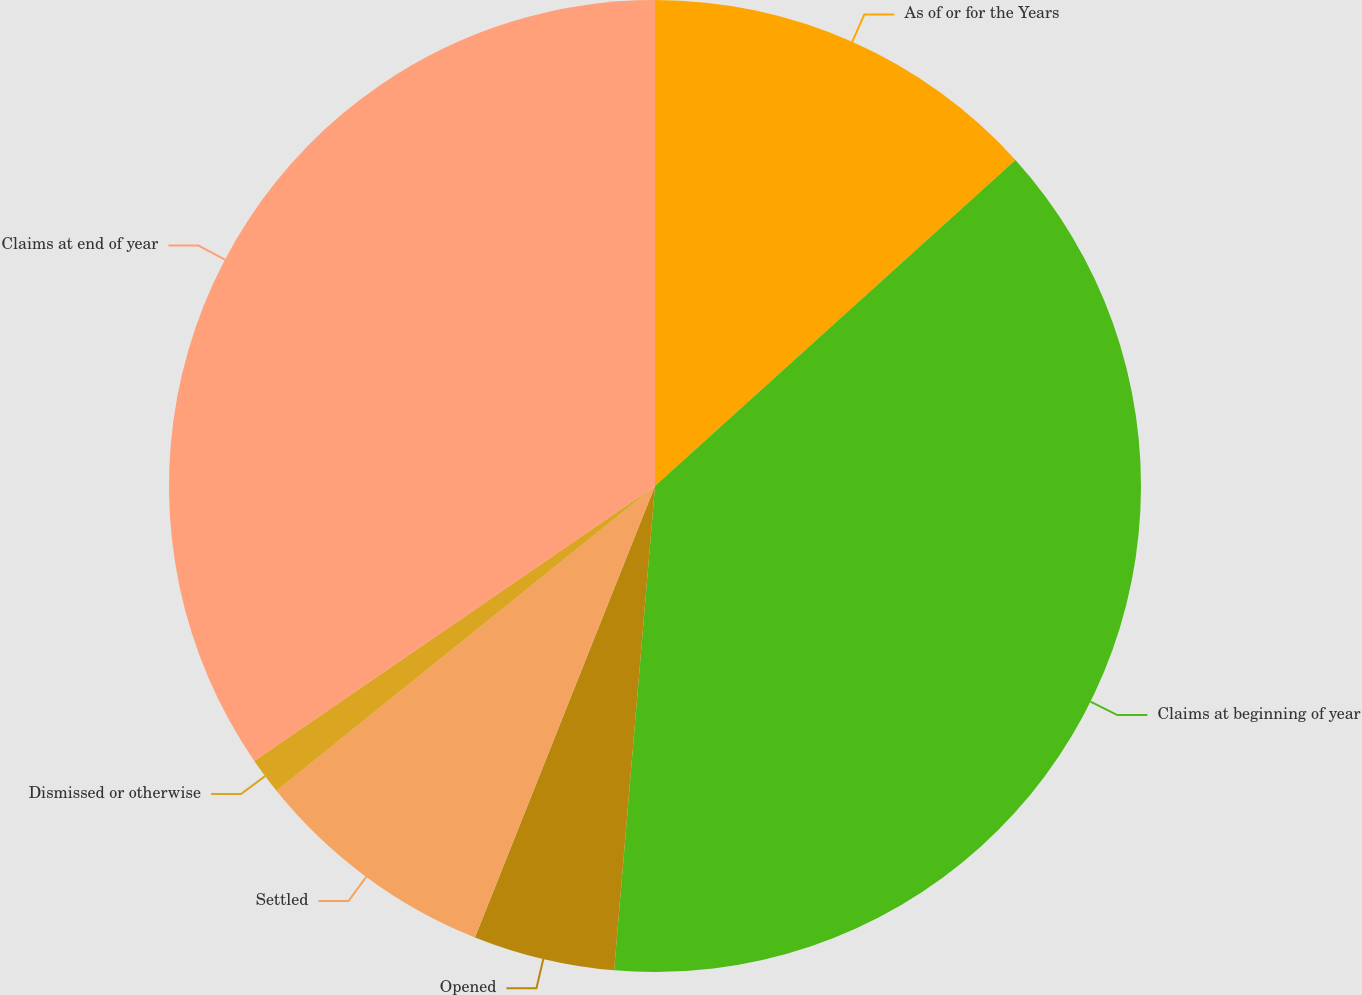Convert chart to OTSL. <chart><loc_0><loc_0><loc_500><loc_500><pie_chart><fcel>As of or for the Years<fcel>Claims at beginning of year<fcel>Opened<fcel>Settled<fcel>Dismissed or otherwise<fcel>Claims at end of year<nl><fcel>13.3%<fcel>38.04%<fcel>4.7%<fcel>8.17%<fcel>1.22%<fcel>34.57%<nl></chart> 